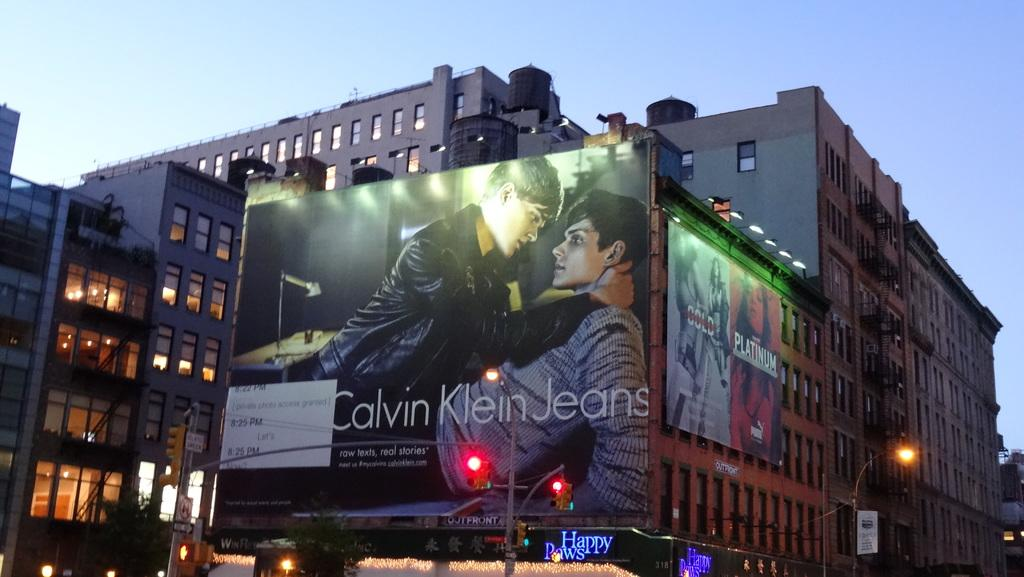<image>
Describe the image concisely. a billboard for calvin klein jeans on it 